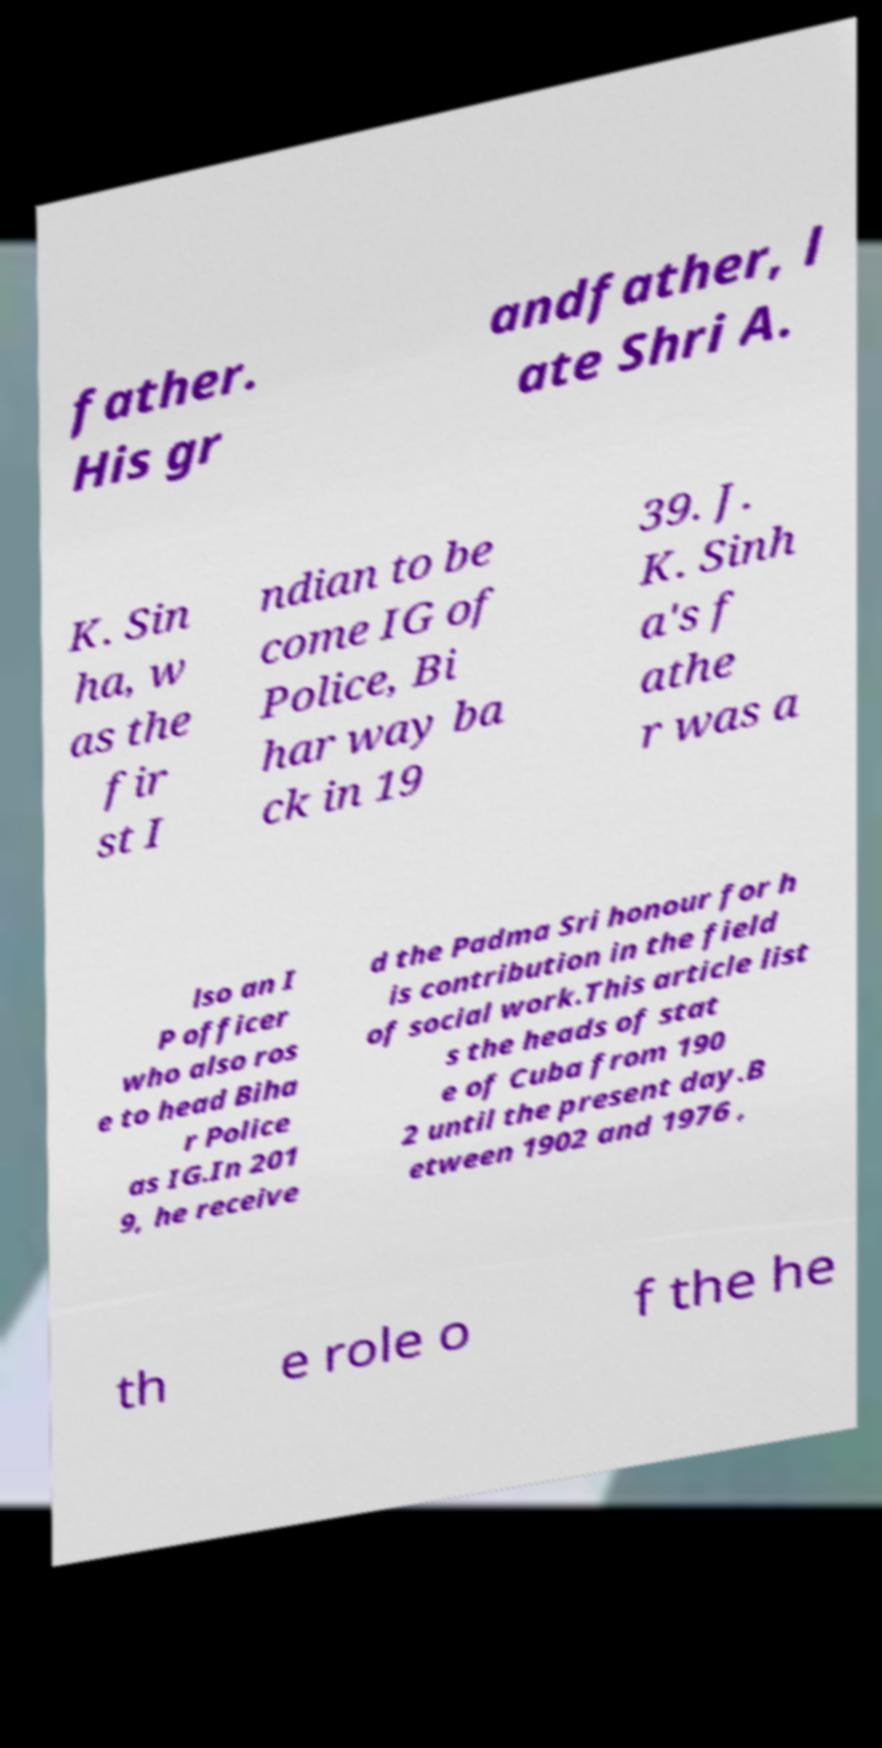Can you accurately transcribe the text from the provided image for me? father. His gr andfather, l ate Shri A. K. Sin ha, w as the fir st I ndian to be come IG of Police, Bi har way ba ck in 19 39. J. K. Sinh a's f athe r was a lso an I P officer who also ros e to head Biha r Police as IG.In 201 9, he receive d the Padma Sri honour for h is contribution in the field of social work.This article list s the heads of stat e of Cuba from 190 2 until the present day.B etween 1902 and 1976 , th e role o f the he 